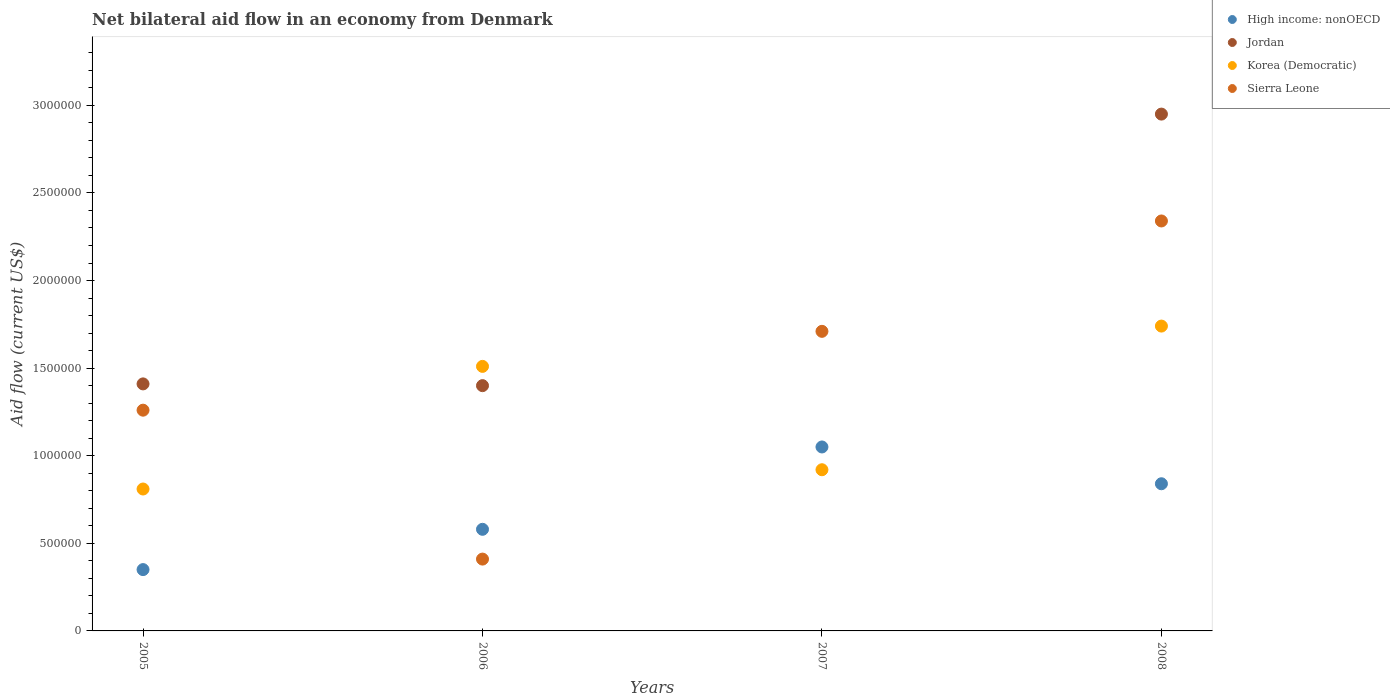How many different coloured dotlines are there?
Provide a succinct answer. 4. What is the net bilateral aid flow in High income: nonOECD in 2008?
Offer a terse response. 8.40e+05. Across all years, what is the maximum net bilateral aid flow in Sierra Leone?
Your response must be concise. 2.34e+06. Across all years, what is the minimum net bilateral aid flow in High income: nonOECD?
Offer a very short reply. 3.50e+05. In which year was the net bilateral aid flow in Jordan maximum?
Ensure brevity in your answer.  2008. What is the total net bilateral aid flow in Korea (Democratic) in the graph?
Your answer should be compact. 4.98e+06. What is the difference between the net bilateral aid flow in High income: nonOECD in 2005 and that in 2007?
Your answer should be very brief. -7.00e+05. What is the difference between the net bilateral aid flow in High income: nonOECD in 2005 and the net bilateral aid flow in Korea (Democratic) in 2007?
Your response must be concise. -5.70e+05. What is the average net bilateral aid flow in High income: nonOECD per year?
Offer a terse response. 7.05e+05. In the year 2005, what is the difference between the net bilateral aid flow in High income: nonOECD and net bilateral aid flow in Korea (Democratic)?
Ensure brevity in your answer.  -4.60e+05. What is the ratio of the net bilateral aid flow in Jordan in 2005 to that in 2008?
Offer a very short reply. 0.48. Is the net bilateral aid flow in Korea (Democratic) in 2007 less than that in 2008?
Your answer should be compact. Yes. What is the difference between the highest and the second highest net bilateral aid flow in Sierra Leone?
Offer a terse response. 6.30e+05. What is the difference between the highest and the lowest net bilateral aid flow in Korea (Democratic)?
Keep it short and to the point. 9.30e+05. In how many years, is the net bilateral aid flow in High income: nonOECD greater than the average net bilateral aid flow in High income: nonOECD taken over all years?
Provide a succinct answer. 2. Is it the case that in every year, the sum of the net bilateral aid flow in Sierra Leone and net bilateral aid flow in Jordan  is greater than the sum of net bilateral aid flow in Korea (Democratic) and net bilateral aid flow in High income: nonOECD?
Keep it short and to the point. No. Is the net bilateral aid flow in Korea (Democratic) strictly less than the net bilateral aid flow in Sierra Leone over the years?
Provide a short and direct response. No. How many years are there in the graph?
Your answer should be compact. 4. Does the graph contain any zero values?
Your answer should be compact. Yes. Does the graph contain grids?
Make the answer very short. No. How many legend labels are there?
Make the answer very short. 4. How are the legend labels stacked?
Your answer should be very brief. Vertical. What is the title of the graph?
Ensure brevity in your answer.  Net bilateral aid flow in an economy from Denmark. What is the label or title of the X-axis?
Offer a terse response. Years. What is the label or title of the Y-axis?
Offer a very short reply. Aid flow (current US$). What is the Aid flow (current US$) of Jordan in 2005?
Offer a terse response. 1.41e+06. What is the Aid flow (current US$) in Korea (Democratic) in 2005?
Your response must be concise. 8.10e+05. What is the Aid flow (current US$) in Sierra Leone in 2005?
Your response must be concise. 1.26e+06. What is the Aid flow (current US$) in High income: nonOECD in 2006?
Provide a short and direct response. 5.80e+05. What is the Aid flow (current US$) of Jordan in 2006?
Your answer should be compact. 1.40e+06. What is the Aid flow (current US$) of Korea (Democratic) in 2006?
Provide a succinct answer. 1.51e+06. What is the Aid flow (current US$) in High income: nonOECD in 2007?
Provide a succinct answer. 1.05e+06. What is the Aid flow (current US$) in Korea (Democratic) in 2007?
Your answer should be very brief. 9.20e+05. What is the Aid flow (current US$) of Sierra Leone in 2007?
Your response must be concise. 1.71e+06. What is the Aid flow (current US$) in High income: nonOECD in 2008?
Make the answer very short. 8.40e+05. What is the Aid flow (current US$) of Jordan in 2008?
Make the answer very short. 2.95e+06. What is the Aid flow (current US$) of Korea (Democratic) in 2008?
Ensure brevity in your answer.  1.74e+06. What is the Aid flow (current US$) of Sierra Leone in 2008?
Offer a very short reply. 2.34e+06. Across all years, what is the maximum Aid flow (current US$) of High income: nonOECD?
Give a very brief answer. 1.05e+06. Across all years, what is the maximum Aid flow (current US$) of Jordan?
Give a very brief answer. 2.95e+06. Across all years, what is the maximum Aid flow (current US$) of Korea (Democratic)?
Your answer should be compact. 1.74e+06. Across all years, what is the maximum Aid flow (current US$) in Sierra Leone?
Provide a short and direct response. 2.34e+06. Across all years, what is the minimum Aid flow (current US$) of High income: nonOECD?
Ensure brevity in your answer.  3.50e+05. Across all years, what is the minimum Aid flow (current US$) in Korea (Democratic)?
Your answer should be very brief. 8.10e+05. Across all years, what is the minimum Aid flow (current US$) of Sierra Leone?
Provide a short and direct response. 4.10e+05. What is the total Aid flow (current US$) of High income: nonOECD in the graph?
Ensure brevity in your answer.  2.82e+06. What is the total Aid flow (current US$) in Jordan in the graph?
Your answer should be very brief. 5.76e+06. What is the total Aid flow (current US$) in Korea (Democratic) in the graph?
Provide a short and direct response. 4.98e+06. What is the total Aid flow (current US$) in Sierra Leone in the graph?
Offer a terse response. 5.72e+06. What is the difference between the Aid flow (current US$) of High income: nonOECD in 2005 and that in 2006?
Ensure brevity in your answer.  -2.30e+05. What is the difference between the Aid flow (current US$) of Jordan in 2005 and that in 2006?
Your answer should be compact. 10000. What is the difference between the Aid flow (current US$) of Korea (Democratic) in 2005 and that in 2006?
Offer a very short reply. -7.00e+05. What is the difference between the Aid flow (current US$) of Sierra Leone in 2005 and that in 2006?
Provide a succinct answer. 8.50e+05. What is the difference between the Aid flow (current US$) of High income: nonOECD in 2005 and that in 2007?
Your answer should be compact. -7.00e+05. What is the difference between the Aid flow (current US$) of Korea (Democratic) in 2005 and that in 2007?
Provide a short and direct response. -1.10e+05. What is the difference between the Aid flow (current US$) of Sierra Leone in 2005 and that in 2007?
Keep it short and to the point. -4.50e+05. What is the difference between the Aid flow (current US$) in High income: nonOECD in 2005 and that in 2008?
Offer a very short reply. -4.90e+05. What is the difference between the Aid flow (current US$) in Jordan in 2005 and that in 2008?
Make the answer very short. -1.54e+06. What is the difference between the Aid flow (current US$) in Korea (Democratic) in 2005 and that in 2008?
Give a very brief answer. -9.30e+05. What is the difference between the Aid flow (current US$) of Sierra Leone in 2005 and that in 2008?
Your response must be concise. -1.08e+06. What is the difference between the Aid flow (current US$) of High income: nonOECD in 2006 and that in 2007?
Your response must be concise. -4.70e+05. What is the difference between the Aid flow (current US$) in Korea (Democratic) in 2006 and that in 2007?
Your answer should be very brief. 5.90e+05. What is the difference between the Aid flow (current US$) of Sierra Leone in 2006 and that in 2007?
Give a very brief answer. -1.30e+06. What is the difference between the Aid flow (current US$) in High income: nonOECD in 2006 and that in 2008?
Ensure brevity in your answer.  -2.60e+05. What is the difference between the Aid flow (current US$) of Jordan in 2006 and that in 2008?
Offer a terse response. -1.55e+06. What is the difference between the Aid flow (current US$) in Korea (Democratic) in 2006 and that in 2008?
Your answer should be compact. -2.30e+05. What is the difference between the Aid flow (current US$) of Sierra Leone in 2006 and that in 2008?
Offer a terse response. -1.93e+06. What is the difference between the Aid flow (current US$) of Korea (Democratic) in 2007 and that in 2008?
Provide a short and direct response. -8.20e+05. What is the difference between the Aid flow (current US$) in Sierra Leone in 2007 and that in 2008?
Your answer should be compact. -6.30e+05. What is the difference between the Aid flow (current US$) of High income: nonOECD in 2005 and the Aid flow (current US$) of Jordan in 2006?
Your answer should be compact. -1.05e+06. What is the difference between the Aid flow (current US$) of High income: nonOECD in 2005 and the Aid flow (current US$) of Korea (Democratic) in 2006?
Offer a very short reply. -1.16e+06. What is the difference between the Aid flow (current US$) in Jordan in 2005 and the Aid flow (current US$) in Korea (Democratic) in 2006?
Your answer should be very brief. -1.00e+05. What is the difference between the Aid flow (current US$) of High income: nonOECD in 2005 and the Aid flow (current US$) of Korea (Democratic) in 2007?
Your response must be concise. -5.70e+05. What is the difference between the Aid flow (current US$) in High income: nonOECD in 2005 and the Aid flow (current US$) in Sierra Leone in 2007?
Offer a terse response. -1.36e+06. What is the difference between the Aid flow (current US$) of Jordan in 2005 and the Aid flow (current US$) of Sierra Leone in 2007?
Offer a terse response. -3.00e+05. What is the difference between the Aid flow (current US$) in Korea (Democratic) in 2005 and the Aid flow (current US$) in Sierra Leone in 2007?
Make the answer very short. -9.00e+05. What is the difference between the Aid flow (current US$) in High income: nonOECD in 2005 and the Aid flow (current US$) in Jordan in 2008?
Make the answer very short. -2.60e+06. What is the difference between the Aid flow (current US$) in High income: nonOECD in 2005 and the Aid flow (current US$) in Korea (Democratic) in 2008?
Keep it short and to the point. -1.39e+06. What is the difference between the Aid flow (current US$) of High income: nonOECD in 2005 and the Aid flow (current US$) of Sierra Leone in 2008?
Offer a terse response. -1.99e+06. What is the difference between the Aid flow (current US$) in Jordan in 2005 and the Aid flow (current US$) in Korea (Democratic) in 2008?
Your answer should be very brief. -3.30e+05. What is the difference between the Aid flow (current US$) of Jordan in 2005 and the Aid flow (current US$) of Sierra Leone in 2008?
Offer a very short reply. -9.30e+05. What is the difference between the Aid flow (current US$) in Korea (Democratic) in 2005 and the Aid flow (current US$) in Sierra Leone in 2008?
Your response must be concise. -1.53e+06. What is the difference between the Aid flow (current US$) of High income: nonOECD in 2006 and the Aid flow (current US$) of Sierra Leone in 2007?
Keep it short and to the point. -1.13e+06. What is the difference between the Aid flow (current US$) in Jordan in 2006 and the Aid flow (current US$) in Korea (Democratic) in 2007?
Your answer should be compact. 4.80e+05. What is the difference between the Aid flow (current US$) in Jordan in 2006 and the Aid flow (current US$) in Sierra Leone in 2007?
Your response must be concise. -3.10e+05. What is the difference between the Aid flow (current US$) of High income: nonOECD in 2006 and the Aid flow (current US$) of Jordan in 2008?
Your response must be concise. -2.37e+06. What is the difference between the Aid flow (current US$) of High income: nonOECD in 2006 and the Aid flow (current US$) of Korea (Democratic) in 2008?
Keep it short and to the point. -1.16e+06. What is the difference between the Aid flow (current US$) of High income: nonOECD in 2006 and the Aid flow (current US$) of Sierra Leone in 2008?
Offer a very short reply. -1.76e+06. What is the difference between the Aid flow (current US$) in Jordan in 2006 and the Aid flow (current US$) in Sierra Leone in 2008?
Give a very brief answer. -9.40e+05. What is the difference between the Aid flow (current US$) of Korea (Democratic) in 2006 and the Aid flow (current US$) of Sierra Leone in 2008?
Offer a terse response. -8.30e+05. What is the difference between the Aid flow (current US$) of High income: nonOECD in 2007 and the Aid flow (current US$) of Jordan in 2008?
Give a very brief answer. -1.90e+06. What is the difference between the Aid flow (current US$) in High income: nonOECD in 2007 and the Aid flow (current US$) in Korea (Democratic) in 2008?
Provide a succinct answer. -6.90e+05. What is the difference between the Aid flow (current US$) of High income: nonOECD in 2007 and the Aid flow (current US$) of Sierra Leone in 2008?
Provide a succinct answer. -1.29e+06. What is the difference between the Aid flow (current US$) of Korea (Democratic) in 2007 and the Aid flow (current US$) of Sierra Leone in 2008?
Offer a very short reply. -1.42e+06. What is the average Aid flow (current US$) of High income: nonOECD per year?
Your response must be concise. 7.05e+05. What is the average Aid flow (current US$) of Jordan per year?
Ensure brevity in your answer.  1.44e+06. What is the average Aid flow (current US$) of Korea (Democratic) per year?
Your answer should be very brief. 1.24e+06. What is the average Aid flow (current US$) of Sierra Leone per year?
Give a very brief answer. 1.43e+06. In the year 2005, what is the difference between the Aid flow (current US$) of High income: nonOECD and Aid flow (current US$) of Jordan?
Keep it short and to the point. -1.06e+06. In the year 2005, what is the difference between the Aid flow (current US$) of High income: nonOECD and Aid flow (current US$) of Korea (Democratic)?
Provide a succinct answer. -4.60e+05. In the year 2005, what is the difference between the Aid flow (current US$) in High income: nonOECD and Aid flow (current US$) in Sierra Leone?
Provide a succinct answer. -9.10e+05. In the year 2005, what is the difference between the Aid flow (current US$) in Jordan and Aid flow (current US$) in Korea (Democratic)?
Your answer should be very brief. 6.00e+05. In the year 2005, what is the difference between the Aid flow (current US$) of Jordan and Aid flow (current US$) of Sierra Leone?
Provide a succinct answer. 1.50e+05. In the year 2005, what is the difference between the Aid flow (current US$) of Korea (Democratic) and Aid flow (current US$) of Sierra Leone?
Your response must be concise. -4.50e+05. In the year 2006, what is the difference between the Aid flow (current US$) of High income: nonOECD and Aid flow (current US$) of Jordan?
Provide a succinct answer. -8.20e+05. In the year 2006, what is the difference between the Aid flow (current US$) in High income: nonOECD and Aid flow (current US$) in Korea (Democratic)?
Ensure brevity in your answer.  -9.30e+05. In the year 2006, what is the difference between the Aid flow (current US$) of High income: nonOECD and Aid flow (current US$) of Sierra Leone?
Ensure brevity in your answer.  1.70e+05. In the year 2006, what is the difference between the Aid flow (current US$) in Jordan and Aid flow (current US$) in Korea (Democratic)?
Your answer should be very brief. -1.10e+05. In the year 2006, what is the difference between the Aid flow (current US$) in Jordan and Aid flow (current US$) in Sierra Leone?
Make the answer very short. 9.90e+05. In the year 2006, what is the difference between the Aid flow (current US$) in Korea (Democratic) and Aid flow (current US$) in Sierra Leone?
Make the answer very short. 1.10e+06. In the year 2007, what is the difference between the Aid flow (current US$) in High income: nonOECD and Aid flow (current US$) in Sierra Leone?
Your answer should be compact. -6.60e+05. In the year 2007, what is the difference between the Aid flow (current US$) in Korea (Democratic) and Aid flow (current US$) in Sierra Leone?
Your answer should be compact. -7.90e+05. In the year 2008, what is the difference between the Aid flow (current US$) of High income: nonOECD and Aid flow (current US$) of Jordan?
Make the answer very short. -2.11e+06. In the year 2008, what is the difference between the Aid flow (current US$) in High income: nonOECD and Aid flow (current US$) in Korea (Democratic)?
Your answer should be very brief. -9.00e+05. In the year 2008, what is the difference between the Aid flow (current US$) of High income: nonOECD and Aid flow (current US$) of Sierra Leone?
Your answer should be compact. -1.50e+06. In the year 2008, what is the difference between the Aid flow (current US$) in Jordan and Aid flow (current US$) in Korea (Democratic)?
Ensure brevity in your answer.  1.21e+06. In the year 2008, what is the difference between the Aid flow (current US$) of Jordan and Aid flow (current US$) of Sierra Leone?
Your answer should be compact. 6.10e+05. In the year 2008, what is the difference between the Aid flow (current US$) of Korea (Democratic) and Aid flow (current US$) of Sierra Leone?
Your response must be concise. -6.00e+05. What is the ratio of the Aid flow (current US$) in High income: nonOECD in 2005 to that in 2006?
Offer a terse response. 0.6. What is the ratio of the Aid flow (current US$) of Jordan in 2005 to that in 2006?
Offer a terse response. 1.01. What is the ratio of the Aid flow (current US$) of Korea (Democratic) in 2005 to that in 2006?
Keep it short and to the point. 0.54. What is the ratio of the Aid flow (current US$) of Sierra Leone in 2005 to that in 2006?
Keep it short and to the point. 3.07. What is the ratio of the Aid flow (current US$) of Korea (Democratic) in 2005 to that in 2007?
Give a very brief answer. 0.88. What is the ratio of the Aid flow (current US$) in Sierra Leone in 2005 to that in 2007?
Provide a succinct answer. 0.74. What is the ratio of the Aid flow (current US$) in High income: nonOECD in 2005 to that in 2008?
Provide a succinct answer. 0.42. What is the ratio of the Aid flow (current US$) of Jordan in 2005 to that in 2008?
Offer a very short reply. 0.48. What is the ratio of the Aid flow (current US$) of Korea (Democratic) in 2005 to that in 2008?
Provide a short and direct response. 0.47. What is the ratio of the Aid flow (current US$) in Sierra Leone in 2005 to that in 2008?
Your answer should be compact. 0.54. What is the ratio of the Aid flow (current US$) in High income: nonOECD in 2006 to that in 2007?
Your answer should be compact. 0.55. What is the ratio of the Aid flow (current US$) in Korea (Democratic) in 2006 to that in 2007?
Your answer should be very brief. 1.64. What is the ratio of the Aid flow (current US$) of Sierra Leone in 2006 to that in 2007?
Offer a very short reply. 0.24. What is the ratio of the Aid flow (current US$) of High income: nonOECD in 2006 to that in 2008?
Ensure brevity in your answer.  0.69. What is the ratio of the Aid flow (current US$) of Jordan in 2006 to that in 2008?
Provide a succinct answer. 0.47. What is the ratio of the Aid flow (current US$) in Korea (Democratic) in 2006 to that in 2008?
Your answer should be very brief. 0.87. What is the ratio of the Aid flow (current US$) of Sierra Leone in 2006 to that in 2008?
Make the answer very short. 0.18. What is the ratio of the Aid flow (current US$) in Korea (Democratic) in 2007 to that in 2008?
Give a very brief answer. 0.53. What is the ratio of the Aid flow (current US$) in Sierra Leone in 2007 to that in 2008?
Provide a short and direct response. 0.73. What is the difference between the highest and the second highest Aid flow (current US$) of High income: nonOECD?
Offer a terse response. 2.10e+05. What is the difference between the highest and the second highest Aid flow (current US$) of Jordan?
Offer a terse response. 1.54e+06. What is the difference between the highest and the second highest Aid flow (current US$) of Korea (Democratic)?
Your answer should be compact. 2.30e+05. What is the difference between the highest and the second highest Aid flow (current US$) in Sierra Leone?
Your response must be concise. 6.30e+05. What is the difference between the highest and the lowest Aid flow (current US$) in Jordan?
Make the answer very short. 2.95e+06. What is the difference between the highest and the lowest Aid flow (current US$) of Korea (Democratic)?
Offer a very short reply. 9.30e+05. What is the difference between the highest and the lowest Aid flow (current US$) of Sierra Leone?
Give a very brief answer. 1.93e+06. 